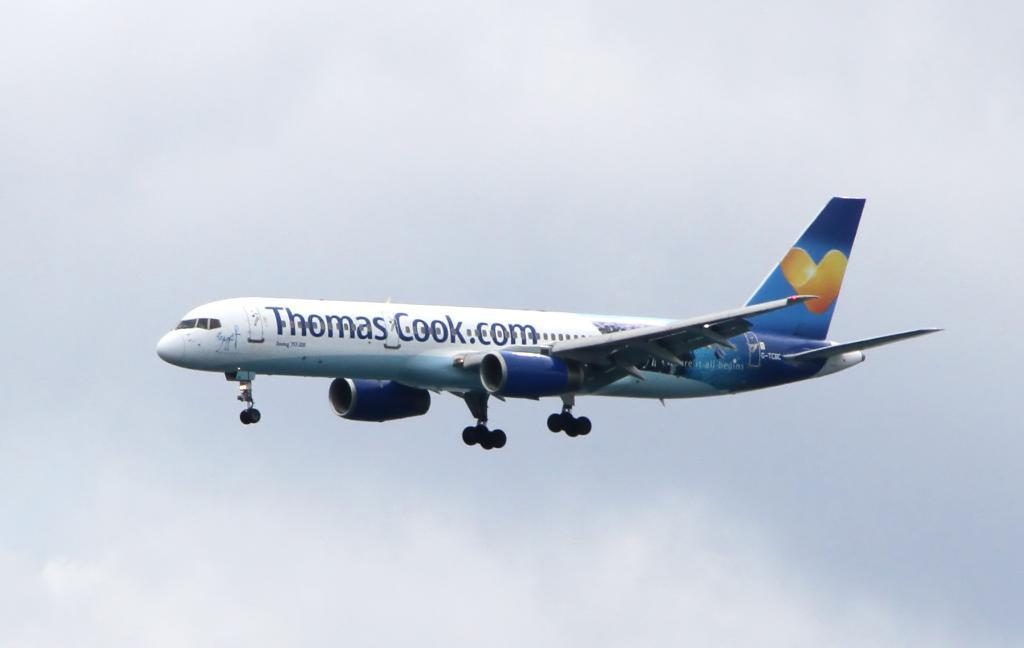<image>
Render a clear and concise summary of the photo. The ad on the side of the plane is for Thomas Cook.com 